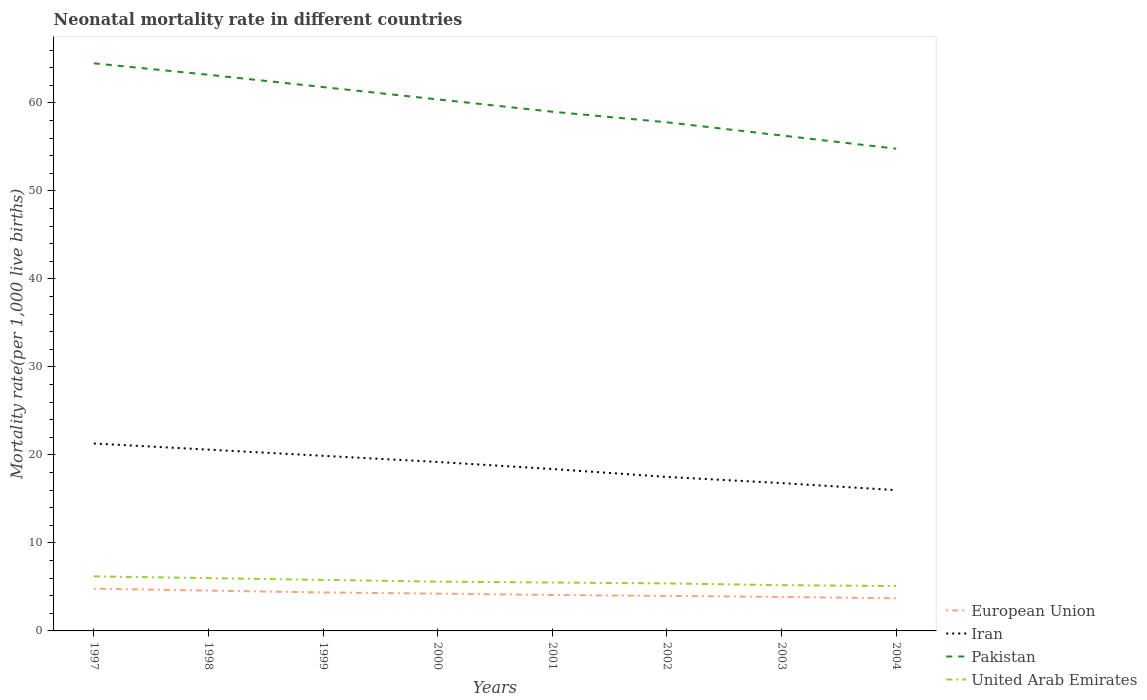How many different coloured lines are there?
Provide a succinct answer. 4. Across all years, what is the maximum neonatal mortality rate in Pakistan?
Provide a short and direct response. 54.8. What is the total neonatal mortality rate in Pakistan in the graph?
Provide a short and direct response. 8.4. What is the difference between the highest and the second highest neonatal mortality rate in European Union?
Provide a short and direct response. 1.09. What is the difference between the highest and the lowest neonatal mortality rate in United Arab Emirates?
Make the answer very short. 3. Is the neonatal mortality rate in United Arab Emirates strictly greater than the neonatal mortality rate in Iran over the years?
Provide a short and direct response. Yes. Are the values on the major ticks of Y-axis written in scientific E-notation?
Your response must be concise. No. Where does the legend appear in the graph?
Provide a succinct answer. Bottom right. How are the legend labels stacked?
Ensure brevity in your answer.  Vertical. What is the title of the graph?
Provide a succinct answer. Neonatal mortality rate in different countries. What is the label or title of the Y-axis?
Keep it short and to the point. Mortality rate(per 1,0 live births). What is the Mortality rate(per 1,000 live births) in European Union in 1997?
Give a very brief answer. 4.8. What is the Mortality rate(per 1,000 live births) of Iran in 1997?
Provide a short and direct response. 21.3. What is the Mortality rate(per 1,000 live births) of Pakistan in 1997?
Your answer should be compact. 64.5. What is the Mortality rate(per 1,000 live births) in United Arab Emirates in 1997?
Your response must be concise. 6.2. What is the Mortality rate(per 1,000 live births) of European Union in 1998?
Ensure brevity in your answer.  4.58. What is the Mortality rate(per 1,000 live births) in Iran in 1998?
Provide a succinct answer. 20.6. What is the Mortality rate(per 1,000 live births) in Pakistan in 1998?
Offer a very short reply. 63.2. What is the Mortality rate(per 1,000 live births) in European Union in 1999?
Your answer should be very brief. 4.37. What is the Mortality rate(per 1,000 live births) in Pakistan in 1999?
Your answer should be very brief. 61.8. What is the Mortality rate(per 1,000 live births) of United Arab Emirates in 1999?
Your answer should be very brief. 5.8. What is the Mortality rate(per 1,000 live births) in European Union in 2000?
Give a very brief answer. 4.24. What is the Mortality rate(per 1,000 live births) of Iran in 2000?
Keep it short and to the point. 19.2. What is the Mortality rate(per 1,000 live births) in Pakistan in 2000?
Offer a terse response. 60.4. What is the Mortality rate(per 1,000 live births) in European Union in 2001?
Make the answer very short. 4.08. What is the Mortality rate(per 1,000 live births) of Iran in 2001?
Provide a succinct answer. 18.4. What is the Mortality rate(per 1,000 live births) in European Union in 2002?
Your response must be concise. 3.98. What is the Mortality rate(per 1,000 live births) in Pakistan in 2002?
Make the answer very short. 57.8. What is the Mortality rate(per 1,000 live births) of United Arab Emirates in 2002?
Your response must be concise. 5.4. What is the Mortality rate(per 1,000 live births) of European Union in 2003?
Keep it short and to the point. 3.86. What is the Mortality rate(per 1,000 live births) in Pakistan in 2003?
Provide a short and direct response. 56.3. What is the Mortality rate(per 1,000 live births) in European Union in 2004?
Provide a succinct answer. 3.71. What is the Mortality rate(per 1,000 live births) of Iran in 2004?
Your response must be concise. 16. What is the Mortality rate(per 1,000 live births) of Pakistan in 2004?
Your response must be concise. 54.8. What is the Mortality rate(per 1,000 live births) in United Arab Emirates in 2004?
Give a very brief answer. 5.1. Across all years, what is the maximum Mortality rate(per 1,000 live births) in European Union?
Your answer should be very brief. 4.8. Across all years, what is the maximum Mortality rate(per 1,000 live births) of Iran?
Your answer should be very brief. 21.3. Across all years, what is the maximum Mortality rate(per 1,000 live births) of Pakistan?
Give a very brief answer. 64.5. Across all years, what is the maximum Mortality rate(per 1,000 live births) of United Arab Emirates?
Offer a terse response. 6.2. Across all years, what is the minimum Mortality rate(per 1,000 live births) in European Union?
Provide a succinct answer. 3.71. Across all years, what is the minimum Mortality rate(per 1,000 live births) of Iran?
Provide a short and direct response. 16. Across all years, what is the minimum Mortality rate(per 1,000 live births) of Pakistan?
Your answer should be very brief. 54.8. Across all years, what is the minimum Mortality rate(per 1,000 live births) of United Arab Emirates?
Make the answer very short. 5.1. What is the total Mortality rate(per 1,000 live births) of European Union in the graph?
Your answer should be compact. 33.62. What is the total Mortality rate(per 1,000 live births) in Iran in the graph?
Your answer should be compact. 149.7. What is the total Mortality rate(per 1,000 live births) in Pakistan in the graph?
Your answer should be very brief. 477.8. What is the total Mortality rate(per 1,000 live births) in United Arab Emirates in the graph?
Ensure brevity in your answer.  44.8. What is the difference between the Mortality rate(per 1,000 live births) of European Union in 1997 and that in 1998?
Provide a short and direct response. 0.22. What is the difference between the Mortality rate(per 1,000 live births) of European Union in 1997 and that in 1999?
Your answer should be very brief. 0.43. What is the difference between the Mortality rate(per 1,000 live births) of Iran in 1997 and that in 1999?
Give a very brief answer. 1.4. What is the difference between the Mortality rate(per 1,000 live births) of European Union in 1997 and that in 2000?
Your response must be concise. 0.56. What is the difference between the Mortality rate(per 1,000 live births) in United Arab Emirates in 1997 and that in 2000?
Provide a short and direct response. 0.6. What is the difference between the Mortality rate(per 1,000 live births) of European Union in 1997 and that in 2001?
Your response must be concise. 0.72. What is the difference between the Mortality rate(per 1,000 live births) in Pakistan in 1997 and that in 2001?
Your answer should be very brief. 5.5. What is the difference between the Mortality rate(per 1,000 live births) of United Arab Emirates in 1997 and that in 2001?
Keep it short and to the point. 0.7. What is the difference between the Mortality rate(per 1,000 live births) of European Union in 1997 and that in 2002?
Keep it short and to the point. 0.82. What is the difference between the Mortality rate(per 1,000 live births) in Iran in 1997 and that in 2002?
Your answer should be compact. 3.8. What is the difference between the Mortality rate(per 1,000 live births) of United Arab Emirates in 1997 and that in 2002?
Keep it short and to the point. 0.8. What is the difference between the Mortality rate(per 1,000 live births) of European Union in 1997 and that in 2003?
Provide a short and direct response. 0.94. What is the difference between the Mortality rate(per 1,000 live births) of Iran in 1997 and that in 2003?
Ensure brevity in your answer.  4.5. What is the difference between the Mortality rate(per 1,000 live births) of European Union in 1997 and that in 2004?
Your answer should be very brief. 1.09. What is the difference between the Mortality rate(per 1,000 live births) in Iran in 1997 and that in 2004?
Offer a very short reply. 5.3. What is the difference between the Mortality rate(per 1,000 live births) of United Arab Emirates in 1997 and that in 2004?
Your response must be concise. 1.1. What is the difference between the Mortality rate(per 1,000 live births) in European Union in 1998 and that in 1999?
Provide a short and direct response. 0.21. What is the difference between the Mortality rate(per 1,000 live births) of United Arab Emirates in 1998 and that in 1999?
Your response must be concise. 0.2. What is the difference between the Mortality rate(per 1,000 live births) of European Union in 1998 and that in 2000?
Provide a short and direct response. 0.34. What is the difference between the Mortality rate(per 1,000 live births) of Pakistan in 1998 and that in 2000?
Your answer should be compact. 2.8. What is the difference between the Mortality rate(per 1,000 live births) in United Arab Emirates in 1998 and that in 2000?
Your response must be concise. 0.4. What is the difference between the Mortality rate(per 1,000 live births) in European Union in 1998 and that in 2001?
Keep it short and to the point. 0.5. What is the difference between the Mortality rate(per 1,000 live births) of United Arab Emirates in 1998 and that in 2001?
Provide a short and direct response. 0.5. What is the difference between the Mortality rate(per 1,000 live births) in European Union in 1998 and that in 2002?
Keep it short and to the point. 0.6. What is the difference between the Mortality rate(per 1,000 live births) of Pakistan in 1998 and that in 2002?
Make the answer very short. 5.4. What is the difference between the Mortality rate(per 1,000 live births) of European Union in 1998 and that in 2003?
Provide a short and direct response. 0.72. What is the difference between the Mortality rate(per 1,000 live births) of Pakistan in 1998 and that in 2003?
Provide a succinct answer. 6.9. What is the difference between the Mortality rate(per 1,000 live births) of United Arab Emirates in 1998 and that in 2003?
Offer a terse response. 0.8. What is the difference between the Mortality rate(per 1,000 live births) of European Union in 1998 and that in 2004?
Ensure brevity in your answer.  0.87. What is the difference between the Mortality rate(per 1,000 live births) of Iran in 1998 and that in 2004?
Offer a very short reply. 4.6. What is the difference between the Mortality rate(per 1,000 live births) of European Union in 1999 and that in 2000?
Provide a short and direct response. 0.13. What is the difference between the Mortality rate(per 1,000 live births) of United Arab Emirates in 1999 and that in 2000?
Provide a short and direct response. 0.2. What is the difference between the Mortality rate(per 1,000 live births) of European Union in 1999 and that in 2001?
Keep it short and to the point. 0.29. What is the difference between the Mortality rate(per 1,000 live births) of European Union in 1999 and that in 2002?
Provide a succinct answer. 0.39. What is the difference between the Mortality rate(per 1,000 live births) of Iran in 1999 and that in 2002?
Provide a succinct answer. 2.4. What is the difference between the Mortality rate(per 1,000 live births) in Pakistan in 1999 and that in 2002?
Offer a very short reply. 4. What is the difference between the Mortality rate(per 1,000 live births) of European Union in 1999 and that in 2003?
Your answer should be compact. 0.51. What is the difference between the Mortality rate(per 1,000 live births) in Iran in 1999 and that in 2003?
Offer a very short reply. 3.1. What is the difference between the Mortality rate(per 1,000 live births) in European Union in 1999 and that in 2004?
Give a very brief answer. 0.66. What is the difference between the Mortality rate(per 1,000 live births) in Iran in 1999 and that in 2004?
Ensure brevity in your answer.  3.9. What is the difference between the Mortality rate(per 1,000 live births) of European Union in 2000 and that in 2001?
Offer a terse response. 0.15. What is the difference between the Mortality rate(per 1,000 live births) of Pakistan in 2000 and that in 2001?
Keep it short and to the point. 1.4. What is the difference between the Mortality rate(per 1,000 live births) in European Union in 2000 and that in 2002?
Keep it short and to the point. 0.26. What is the difference between the Mortality rate(per 1,000 live births) in European Union in 2000 and that in 2003?
Make the answer very short. 0.38. What is the difference between the Mortality rate(per 1,000 live births) of Iran in 2000 and that in 2003?
Keep it short and to the point. 2.4. What is the difference between the Mortality rate(per 1,000 live births) in United Arab Emirates in 2000 and that in 2003?
Provide a short and direct response. 0.4. What is the difference between the Mortality rate(per 1,000 live births) of European Union in 2000 and that in 2004?
Offer a terse response. 0.53. What is the difference between the Mortality rate(per 1,000 live births) in Pakistan in 2000 and that in 2004?
Keep it short and to the point. 5.6. What is the difference between the Mortality rate(per 1,000 live births) of European Union in 2001 and that in 2002?
Ensure brevity in your answer.  0.11. What is the difference between the Mortality rate(per 1,000 live births) of Iran in 2001 and that in 2002?
Your answer should be compact. 0.9. What is the difference between the Mortality rate(per 1,000 live births) in European Union in 2001 and that in 2003?
Make the answer very short. 0.22. What is the difference between the Mortality rate(per 1,000 live births) in United Arab Emirates in 2001 and that in 2003?
Make the answer very short. 0.3. What is the difference between the Mortality rate(per 1,000 live births) of European Union in 2001 and that in 2004?
Provide a short and direct response. 0.37. What is the difference between the Mortality rate(per 1,000 live births) of Iran in 2001 and that in 2004?
Keep it short and to the point. 2.4. What is the difference between the Mortality rate(per 1,000 live births) in European Union in 2002 and that in 2003?
Provide a short and direct response. 0.12. What is the difference between the Mortality rate(per 1,000 live births) of Iran in 2002 and that in 2003?
Offer a terse response. 0.7. What is the difference between the Mortality rate(per 1,000 live births) of United Arab Emirates in 2002 and that in 2003?
Keep it short and to the point. 0.2. What is the difference between the Mortality rate(per 1,000 live births) of European Union in 2002 and that in 2004?
Your answer should be very brief. 0.27. What is the difference between the Mortality rate(per 1,000 live births) of Pakistan in 2002 and that in 2004?
Give a very brief answer. 3. What is the difference between the Mortality rate(per 1,000 live births) of European Union in 2003 and that in 2004?
Provide a succinct answer. 0.15. What is the difference between the Mortality rate(per 1,000 live births) in Iran in 2003 and that in 2004?
Ensure brevity in your answer.  0.8. What is the difference between the Mortality rate(per 1,000 live births) in Pakistan in 2003 and that in 2004?
Ensure brevity in your answer.  1.5. What is the difference between the Mortality rate(per 1,000 live births) of European Union in 1997 and the Mortality rate(per 1,000 live births) of Iran in 1998?
Ensure brevity in your answer.  -15.8. What is the difference between the Mortality rate(per 1,000 live births) of European Union in 1997 and the Mortality rate(per 1,000 live births) of Pakistan in 1998?
Provide a succinct answer. -58.4. What is the difference between the Mortality rate(per 1,000 live births) of European Union in 1997 and the Mortality rate(per 1,000 live births) of United Arab Emirates in 1998?
Your answer should be compact. -1.2. What is the difference between the Mortality rate(per 1,000 live births) in Iran in 1997 and the Mortality rate(per 1,000 live births) in Pakistan in 1998?
Ensure brevity in your answer.  -41.9. What is the difference between the Mortality rate(per 1,000 live births) of Iran in 1997 and the Mortality rate(per 1,000 live births) of United Arab Emirates in 1998?
Your answer should be very brief. 15.3. What is the difference between the Mortality rate(per 1,000 live births) of Pakistan in 1997 and the Mortality rate(per 1,000 live births) of United Arab Emirates in 1998?
Give a very brief answer. 58.5. What is the difference between the Mortality rate(per 1,000 live births) in European Union in 1997 and the Mortality rate(per 1,000 live births) in Iran in 1999?
Provide a short and direct response. -15.1. What is the difference between the Mortality rate(per 1,000 live births) of European Union in 1997 and the Mortality rate(per 1,000 live births) of Pakistan in 1999?
Keep it short and to the point. -57. What is the difference between the Mortality rate(per 1,000 live births) of European Union in 1997 and the Mortality rate(per 1,000 live births) of United Arab Emirates in 1999?
Make the answer very short. -1. What is the difference between the Mortality rate(per 1,000 live births) in Iran in 1997 and the Mortality rate(per 1,000 live births) in Pakistan in 1999?
Make the answer very short. -40.5. What is the difference between the Mortality rate(per 1,000 live births) in Pakistan in 1997 and the Mortality rate(per 1,000 live births) in United Arab Emirates in 1999?
Offer a terse response. 58.7. What is the difference between the Mortality rate(per 1,000 live births) of European Union in 1997 and the Mortality rate(per 1,000 live births) of Iran in 2000?
Your response must be concise. -14.4. What is the difference between the Mortality rate(per 1,000 live births) of European Union in 1997 and the Mortality rate(per 1,000 live births) of Pakistan in 2000?
Provide a short and direct response. -55.6. What is the difference between the Mortality rate(per 1,000 live births) of European Union in 1997 and the Mortality rate(per 1,000 live births) of United Arab Emirates in 2000?
Your answer should be compact. -0.8. What is the difference between the Mortality rate(per 1,000 live births) in Iran in 1997 and the Mortality rate(per 1,000 live births) in Pakistan in 2000?
Keep it short and to the point. -39.1. What is the difference between the Mortality rate(per 1,000 live births) in Pakistan in 1997 and the Mortality rate(per 1,000 live births) in United Arab Emirates in 2000?
Your answer should be compact. 58.9. What is the difference between the Mortality rate(per 1,000 live births) of European Union in 1997 and the Mortality rate(per 1,000 live births) of Iran in 2001?
Ensure brevity in your answer.  -13.6. What is the difference between the Mortality rate(per 1,000 live births) of European Union in 1997 and the Mortality rate(per 1,000 live births) of Pakistan in 2001?
Ensure brevity in your answer.  -54.2. What is the difference between the Mortality rate(per 1,000 live births) of European Union in 1997 and the Mortality rate(per 1,000 live births) of United Arab Emirates in 2001?
Offer a very short reply. -0.7. What is the difference between the Mortality rate(per 1,000 live births) in Iran in 1997 and the Mortality rate(per 1,000 live births) in Pakistan in 2001?
Keep it short and to the point. -37.7. What is the difference between the Mortality rate(per 1,000 live births) in Pakistan in 1997 and the Mortality rate(per 1,000 live births) in United Arab Emirates in 2001?
Your answer should be compact. 59. What is the difference between the Mortality rate(per 1,000 live births) in European Union in 1997 and the Mortality rate(per 1,000 live births) in Iran in 2002?
Offer a very short reply. -12.7. What is the difference between the Mortality rate(per 1,000 live births) of European Union in 1997 and the Mortality rate(per 1,000 live births) of Pakistan in 2002?
Offer a very short reply. -53. What is the difference between the Mortality rate(per 1,000 live births) of European Union in 1997 and the Mortality rate(per 1,000 live births) of United Arab Emirates in 2002?
Ensure brevity in your answer.  -0.6. What is the difference between the Mortality rate(per 1,000 live births) of Iran in 1997 and the Mortality rate(per 1,000 live births) of Pakistan in 2002?
Give a very brief answer. -36.5. What is the difference between the Mortality rate(per 1,000 live births) in Pakistan in 1997 and the Mortality rate(per 1,000 live births) in United Arab Emirates in 2002?
Ensure brevity in your answer.  59.1. What is the difference between the Mortality rate(per 1,000 live births) in European Union in 1997 and the Mortality rate(per 1,000 live births) in Iran in 2003?
Your answer should be compact. -12. What is the difference between the Mortality rate(per 1,000 live births) of European Union in 1997 and the Mortality rate(per 1,000 live births) of Pakistan in 2003?
Offer a terse response. -51.5. What is the difference between the Mortality rate(per 1,000 live births) in European Union in 1997 and the Mortality rate(per 1,000 live births) in United Arab Emirates in 2003?
Provide a succinct answer. -0.4. What is the difference between the Mortality rate(per 1,000 live births) in Iran in 1997 and the Mortality rate(per 1,000 live births) in Pakistan in 2003?
Your response must be concise. -35. What is the difference between the Mortality rate(per 1,000 live births) in Pakistan in 1997 and the Mortality rate(per 1,000 live births) in United Arab Emirates in 2003?
Keep it short and to the point. 59.3. What is the difference between the Mortality rate(per 1,000 live births) in European Union in 1997 and the Mortality rate(per 1,000 live births) in Iran in 2004?
Keep it short and to the point. -11.2. What is the difference between the Mortality rate(per 1,000 live births) of European Union in 1997 and the Mortality rate(per 1,000 live births) of Pakistan in 2004?
Make the answer very short. -50. What is the difference between the Mortality rate(per 1,000 live births) in European Union in 1997 and the Mortality rate(per 1,000 live births) in United Arab Emirates in 2004?
Provide a short and direct response. -0.3. What is the difference between the Mortality rate(per 1,000 live births) of Iran in 1997 and the Mortality rate(per 1,000 live births) of Pakistan in 2004?
Provide a short and direct response. -33.5. What is the difference between the Mortality rate(per 1,000 live births) in Pakistan in 1997 and the Mortality rate(per 1,000 live births) in United Arab Emirates in 2004?
Keep it short and to the point. 59.4. What is the difference between the Mortality rate(per 1,000 live births) of European Union in 1998 and the Mortality rate(per 1,000 live births) of Iran in 1999?
Your answer should be compact. -15.32. What is the difference between the Mortality rate(per 1,000 live births) in European Union in 1998 and the Mortality rate(per 1,000 live births) in Pakistan in 1999?
Make the answer very short. -57.22. What is the difference between the Mortality rate(per 1,000 live births) of European Union in 1998 and the Mortality rate(per 1,000 live births) of United Arab Emirates in 1999?
Ensure brevity in your answer.  -1.22. What is the difference between the Mortality rate(per 1,000 live births) in Iran in 1998 and the Mortality rate(per 1,000 live births) in Pakistan in 1999?
Your response must be concise. -41.2. What is the difference between the Mortality rate(per 1,000 live births) in Pakistan in 1998 and the Mortality rate(per 1,000 live births) in United Arab Emirates in 1999?
Ensure brevity in your answer.  57.4. What is the difference between the Mortality rate(per 1,000 live births) of European Union in 1998 and the Mortality rate(per 1,000 live births) of Iran in 2000?
Give a very brief answer. -14.62. What is the difference between the Mortality rate(per 1,000 live births) of European Union in 1998 and the Mortality rate(per 1,000 live births) of Pakistan in 2000?
Make the answer very short. -55.82. What is the difference between the Mortality rate(per 1,000 live births) in European Union in 1998 and the Mortality rate(per 1,000 live births) in United Arab Emirates in 2000?
Your answer should be compact. -1.02. What is the difference between the Mortality rate(per 1,000 live births) of Iran in 1998 and the Mortality rate(per 1,000 live births) of Pakistan in 2000?
Your response must be concise. -39.8. What is the difference between the Mortality rate(per 1,000 live births) of Pakistan in 1998 and the Mortality rate(per 1,000 live births) of United Arab Emirates in 2000?
Keep it short and to the point. 57.6. What is the difference between the Mortality rate(per 1,000 live births) in European Union in 1998 and the Mortality rate(per 1,000 live births) in Iran in 2001?
Your answer should be compact. -13.82. What is the difference between the Mortality rate(per 1,000 live births) in European Union in 1998 and the Mortality rate(per 1,000 live births) in Pakistan in 2001?
Offer a terse response. -54.42. What is the difference between the Mortality rate(per 1,000 live births) of European Union in 1998 and the Mortality rate(per 1,000 live births) of United Arab Emirates in 2001?
Give a very brief answer. -0.92. What is the difference between the Mortality rate(per 1,000 live births) in Iran in 1998 and the Mortality rate(per 1,000 live births) in Pakistan in 2001?
Provide a short and direct response. -38.4. What is the difference between the Mortality rate(per 1,000 live births) in Iran in 1998 and the Mortality rate(per 1,000 live births) in United Arab Emirates in 2001?
Your answer should be very brief. 15.1. What is the difference between the Mortality rate(per 1,000 live births) of Pakistan in 1998 and the Mortality rate(per 1,000 live births) of United Arab Emirates in 2001?
Ensure brevity in your answer.  57.7. What is the difference between the Mortality rate(per 1,000 live births) in European Union in 1998 and the Mortality rate(per 1,000 live births) in Iran in 2002?
Offer a terse response. -12.92. What is the difference between the Mortality rate(per 1,000 live births) in European Union in 1998 and the Mortality rate(per 1,000 live births) in Pakistan in 2002?
Keep it short and to the point. -53.22. What is the difference between the Mortality rate(per 1,000 live births) of European Union in 1998 and the Mortality rate(per 1,000 live births) of United Arab Emirates in 2002?
Make the answer very short. -0.82. What is the difference between the Mortality rate(per 1,000 live births) in Iran in 1998 and the Mortality rate(per 1,000 live births) in Pakistan in 2002?
Your response must be concise. -37.2. What is the difference between the Mortality rate(per 1,000 live births) in Iran in 1998 and the Mortality rate(per 1,000 live births) in United Arab Emirates in 2002?
Ensure brevity in your answer.  15.2. What is the difference between the Mortality rate(per 1,000 live births) of Pakistan in 1998 and the Mortality rate(per 1,000 live births) of United Arab Emirates in 2002?
Ensure brevity in your answer.  57.8. What is the difference between the Mortality rate(per 1,000 live births) of European Union in 1998 and the Mortality rate(per 1,000 live births) of Iran in 2003?
Provide a short and direct response. -12.22. What is the difference between the Mortality rate(per 1,000 live births) of European Union in 1998 and the Mortality rate(per 1,000 live births) of Pakistan in 2003?
Keep it short and to the point. -51.72. What is the difference between the Mortality rate(per 1,000 live births) in European Union in 1998 and the Mortality rate(per 1,000 live births) in United Arab Emirates in 2003?
Offer a very short reply. -0.62. What is the difference between the Mortality rate(per 1,000 live births) of Iran in 1998 and the Mortality rate(per 1,000 live births) of Pakistan in 2003?
Keep it short and to the point. -35.7. What is the difference between the Mortality rate(per 1,000 live births) in Pakistan in 1998 and the Mortality rate(per 1,000 live births) in United Arab Emirates in 2003?
Provide a succinct answer. 58. What is the difference between the Mortality rate(per 1,000 live births) of European Union in 1998 and the Mortality rate(per 1,000 live births) of Iran in 2004?
Make the answer very short. -11.42. What is the difference between the Mortality rate(per 1,000 live births) in European Union in 1998 and the Mortality rate(per 1,000 live births) in Pakistan in 2004?
Provide a succinct answer. -50.22. What is the difference between the Mortality rate(per 1,000 live births) of European Union in 1998 and the Mortality rate(per 1,000 live births) of United Arab Emirates in 2004?
Ensure brevity in your answer.  -0.52. What is the difference between the Mortality rate(per 1,000 live births) in Iran in 1998 and the Mortality rate(per 1,000 live births) in Pakistan in 2004?
Keep it short and to the point. -34.2. What is the difference between the Mortality rate(per 1,000 live births) in Iran in 1998 and the Mortality rate(per 1,000 live births) in United Arab Emirates in 2004?
Make the answer very short. 15.5. What is the difference between the Mortality rate(per 1,000 live births) in Pakistan in 1998 and the Mortality rate(per 1,000 live births) in United Arab Emirates in 2004?
Ensure brevity in your answer.  58.1. What is the difference between the Mortality rate(per 1,000 live births) of European Union in 1999 and the Mortality rate(per 1,000 live births) of Iran in 2000?
Your response must be concise. -14.83. What is the difference between the Mortality rate(per 1,000 live births) of European Union in 1999 and the Mortality rate(per 1,000 live births) of Pakistan in 2000?
Your answer should be very brief. -56.03. What is the difference between the Mortality rate(per 1,000 live births) in European Union in 1999 and the Mortality rate(per 1,000 live births) in United Arab Emirates in 2000?
Make the answer very short. -1.23. What is the difference between the Mortality rate(per 1,000 live births) of Iran in 1999 and the Mortality rate(per 1,000 live births) of Pakistan in 2000?
Your response must be concise. -40.5. What is the difference between the Mortality rate(per 1,000 live births) of Iran in 1999 and the Mortality rate(per 1,000 live births) of United Arab Emirates in 2000?
Offer a very short reply. 14.3. What is the difference between the Mortality rate(per 1,000 live births) of Pakistan in 1999 and the Mortality rate(per 1,000 live births) of United Arab Emirates in 2000?
Keep it short and to the point. 56.2. What is the difference between the Mortality rate(per 1,000 live births) in European Union in 1999 and the Mortality rate(per 1,000 live births) in Iran in 2001?
Offer a terse response. -14.03. What is the difference between the Mortality rate(per 1,000 live births) of European Union in 1999 and the Mortality rate(per 1,000 live births) of Pakistan in 2001?
Your response must be concise. -54.63. What is the difference between the Mortality rate(per 1,000 live births) of European Union in 1999 and the Mortality rate(per 1,000 live births) of United Arab Emirates in 2001?
Provide a succinct answer. -1.13. What is the difference between the Mortality rate(per 1,000 live births) of Iran in 1999 and the Mortality rate(per 1,000 live births) of Pakistan in 2001?
Provide a short and direct response. -39.1. What is the difference between the Mortality rate(per 1,000 live births) in Pakistan in 1999 and the Mortality rate(per 1,000 live births) in United Arab Emirates in 2001?
Provide a succinct answer. 56.3. What is the difference between the Mortality rate(per 1,000 live births) in European Union in 1999 and the Mortality rate(per 1,000 live births) in Iran in 2002?
Offer a very short reply. -13.13. What is the difference between the Mortality rate(per 1,000 live births) in European Union in 1999 and the Mortality rate(per 1,000 live births) in Pakistan in 2002?
Your response must be concise. -53.43. What is the difference between the Mortality rate(per 1,000 live births) in European Union in 1999 and the Mortality rate(per 1,000 live births) in United Arab Emirates in 2002?
Ensure brevity in your answer.  -1.03. What is the difference between the Mortality rate(per 1,000 live births) in Iran in 1999 and the Mortality rate(per 1,000 live births) in Pakistan in 2002?
Your answer should be very brief. -37.9. What is the difference between the Mortality rate(per 1,000 live births) of Iran in 1999 and the Mortality rate(per 1,000 live births) of United Arab Emirates in 2002?
Your response must be concise. 14.5. What is the difference between the Mortality rate(per 1,000 live births) in Pakistan in 1999 and the Mortality rate(per 1,000 live births) in United Arab Emirates in 2002?
Give a very brief answer. 56.4. What is the difference between the Mortality rate(per 1,000 live births) in European Union in 1999 and the Mortality rate(per 1,000 live births) in Iran in 2003?
Keep it short and to the point. -12.43. What is the difference between the Mortality rate(per 1,000 live births) of European Union in 1999 and the Mortality rate(per 1,000 live births) of Pakistan in 2003?
Give a very brief answer. -51.93. What is the difference between the Mortality rate(per 1,000 live births) in European Union in 1999 and the Mortality rate(per 1,000 live births) in United Arab Emirates in 2003?
Your response must be concise. -0.83. What is the difference between the Mortality rate(per 1,000 live births) in Iran in 1999 and the Mortality rate(per 1,000 live births) in Pakistan in 2003?
Keep it short and to the point. -36.4. What is the difference between the Mortality rate(per 1,000 live births) of Pakistan in 1999 and the Mortality rate(per 1,000 live births) of United Arab Emirates in 2003?
Your answer should be very brief. 56.6. What is the difference between the Mortality rate(per 1,000 live births) in European Union in 1999 and the Mortality rate(per 1,000 live births) in Iran in 2004?
Provide a succinct answer. -11.63. What is the difference between the Mortality rate(per 1,000 live births) of European Union in 1999 and the Mortality rate(per 1,000 live births) of Pakistan in 2004?
Keep it short and to the point. -50.43. What is the difference between the Mortality rate(per 1,000 live births) of European Union in 1999 and the Mortality rate(per 1,000 live births) of United Arab Emirates in 2004?
Ensure brevity in your answer.  -0.73. What is the difference between the Mortality rate(per 1,000 live births) of Iran in 1999 and the Mortality rate(per 1,000 live births) of Pakistan in 2004?
Offer a terse response. -34.9. What is the difference between the Mortality rate(per 1,000 live births) of Iran in 1999 and the Mortality rate(per 1,000 live births) of United Arab Emirates in 2004?
Your answer should be compact. 14.8. What is the difference between the Mortality rate(per 1,000 live births) in Pakistan in 1999 and the Mortality rate(per 1,000 live births) in United Arab Emirates in 2004?
Offer a very short reply. 56.7. What is the difference between the Mortality rate(per 1,000 live births) in European Union in 2000 and the Mortality rate(per 1,000 live births) in Iran in 2001?
Your answer should be compact. -14.16. What is the difference between the Mortality rate(per 1,000 live births) in European Union in 2000 and the Mortality rate(per 1,000 live births) in Pakistan in 2001?
Provide a short and direct response. -54.76. What is the difference between the Mortality rate(per 1,000 live births) of European Union in 2000 and the Mortality rate(per 1,000 live births) of United Arab Emirates in 2001?
Make the answer very short. -1.26. What is the difference between the Mortality rate(per 1,000 live births) of Iran in 2000 and the Mortality rate(per 1,000 live births) of Pakistan in 2001?
Offer a terse response. -39.8. What is the difference between the Mortality rate(per 1,000 live births) in Iran in 2000 and the Mortality rate(per 1,000 live births) in United Arab Emirates in 2001?
Provide a succinct answer. 13.7. What is the difference between the Mortality rate(per 1,000 live births) of Pakistan in 2000 and the Mortality rate(per 1,000 live births) of United Arab Emirates in 2001?
Make the answer very short. 54.9. What is the difference between the Mortality rate(per 1,000 live births) in European Union in 2000 and the Mortality rate(per 1,000 live births) in Iran in 2002?
Keep it short and to the point. -13.26. What is the difference between the Mortality rate(per 1,000 live births) in European Union in 2000 and the Mortality rate(per 1,000 live births) in Pakistan in 2002?
Ensure brevity in your answer.  -53.56. What is the difference between the Mortality rate(per 1,000 live births) in European Union in 2000 and the Mortality rate(per 1,000 live births) in United Arab Emirates in 2002?
Your answer should be compact. -1.16. What is the difference between the Mortality rate(per 1,000 live births) of Iran in 2000 and the Mortality rate(per 1,000 live births) of Pakistan in 2002?
Make the answer very short. -38.6. What is the difference between the Mortality rate(per 1,000 live births) of European Union in 2000 and the Mortality rate(per 1,000 live births) of Iran in 2003?
Your answer should be very brief. -12.56. What is the difference between the Mortality rate(per 1,000 live births) in European Union in 2000 and the Mortality rate(per 1,000 live births) in Pakistan in 2003?
Keep it short and to the point. -52.06. What is the difference between the Mortality rate(per 1,000 live births) of European Union in 2000 and the Mortality rate(per 1,000 live births) of United Arab Emirates in 2003?
Your answer should be compact. -0.96. What is the difference between the Mortality rate(per 1,000 live births) of Iran in 2000 and the Mortality rate(per 1,000 live births) of Pakistan in 2003?
Your response must be concise. -37.1. What is the difference between the Mortality rate(per 1,000 live births) of Pakistan in 2000 and the Mortality rate(per 1,000 live births) of United Arab Emirates in 2003?
Offer a very short reply. 55.2. What is the difference between the Mortality rate(per 1,000 live births) in European Union in 2000 and the Mortality rate(per 1,000 live births) in Iran in 2004?
Provide a short and direct response. -11.76. What is the difference between the Mortality rate(per 1,000 live births) of European Union in 2000 and the Mortality rate(per 1,000 live births) of Pakistan in 2004?
Give a very brief answer. -50.56. What is the difference between the Mortality rate(per 1,000 live births) of European Union in 2000 and the Mortality rate(per 1,000 live births) of United Arab Emirates in 2004?
Offer a terse response. -0.86. What is the difference between the Mortality rate(per 1,000 live births) in Iran in 2000 and the Mortality rate(per 1,000 live births) in Pakistan in 2004?
Offer a very short reply. -35.6. What is the difference between the Mortality rate(per 1,000 live births) in Iran in 2000 and the Mortality rate(per 1,000 live births) in United Arab Emirates in 2004?
Provide a succinct answer. 14.1. What is the difference between the Mortality rate(per 1,000 live births) in Pakistan in 2000 and the Mortality rate(per 1,000 live births) in United Arab Emirates in 2004?
Provide a short and direct response. 55.3. What is the difference between the Mortality rate(per 1,000 live births) of European Union in 2001 and the Mortality rate(per 1,000 live births) of Iran in 2002?
Ensure brevity in your answer.  -13.42. What is the difference between the Mortality rate(per 1,000 live births) in European Union in 2001 and the Mortality rate(per 1,000 live births) in Pakistan in 2002?
Your answer should be compact. -53.72. What is the difference between the Mortality rate(per 1,000 live births) of European Union in 2001 and the Mortality rate(per 1,000 live births) of United Arab Emirates in 2002?
Your response must be concise. -1.32. What is the difference between the Mortality rate(per 1,000 live births) in Iran in 2001 and the Mortality rate(per 1,000 live births) in Pakistan in 2002?
Offer a terse response. -39.4. What is the difference between the Mortality rate(per 1,000 live births) of Pakistan in 2001 and the Mortality rate(per 1,000 live births) of United Arab Emirates in 2002?
Provide a succinct answer. 53.6. What is the difference between the Mortality rate(per 1,000 live births) of European Union in 2001 and the Mortality rate(per 1,000 live births) of Iran in 2003?
Provide a short and direct response. -12.72. What is the difference between the Mortality rate(per 1,000 live births) in European Union in 2001 and the Mortality rate(per 1,000 live births) in Pakistan in 2003?
Keep it short and to the point. -52.22. What is the difference between the Mortality rate(per 1,000 live births) in European Union in 2001 and the Mortality rate(per 1,000 live births) in United Arab Emirates in 2003?
Offer a very short reply. -1.12. What is the difference between the Mortality rate(per 1,000 live births) in Iran in 2001 and the Mortality rate(per 1,000 live births) in Pakistan in 2003?
Give a very brief answer. -37.9. What is the difference between the Mortality rate(per 1,000 live births) in Pakistan in 2001 and the Mortality rate(per 1,000 live births) in United Arab Emirates in 2003?
Your answer should be compact. 53.8. What is the difference between the Mortality rate(per 1,000 live births) in European Union in 2001 and the Mortality rate(per 1,000 live births) in Iran in 2004?
Offer a very short reply. -11.92. What is the difference between the Mortality rate(per 1,000 live births) of European Union in 2001 and the Mortality rate(per 1,000 live births) of Pakistan in 2004?
Ensure brevity in your answer.  -50.72. What is the difference between the Mortality rate(per 1,000 live births) in European Union in 2001 and the Mortality rate(per 1,000 live births) in United Arab Emirates in 2004?
Your answer should be compact. -1.02. What is the difference between the Mortality rate(per 1,000 live births) in Iran in 2001 and the Mortality rate(per 1,000 live births) in Pakistan in 2004?
Your response must be concise. -36.4. What is the difference between the Mortality rate(per 1,000 live births) in Iran in 2001 and the Mortality rate(per 1,000 live births) in United Arab Emirates in 2004?
Keep it short and to the point. 13.3. What is the difference between the Mortality rate(per 1,000 live births) of Pakistan in 2001 and the Mortality rate(per 1,000 live births) of United Arab Emirates in 2004?
Keep it short and to the point. 53.9. What is the difference between the Mortality rate(per 1,000 live births) of European Union in 2002 and the Mortality rate(per 1,000 live births) of Iran in 2003?
Give a very brief answer. -12.82. What is the difference between the Mortality rate(per 1,000 live births) of European Union in 2002 and the Mortality rate(per 1,000 live births) of Pakistan in 2003?
Provide a short and direct response. -52.32. What is the difference between the Mortality rate(per 1,000 live births) of European Union in 2002 and the Mortality rate(per 1,000 live births) of United Arab Emirates in 2003?
Your answer should be very brief. -1.22. What is the difference between the Mortality rate(per 1,000 live births) in Iran in 2002 and the Mortality rate(per 1,000 live births) in Pakistan in 2003?
Your response must be concise. -38.8. What is the difference between the Mortality rate(per 1,000 live births) in Pakistan in 2002 and the Mortality rate(per 1,000 live births) in United Arab Emirates in 2003?
Provide a short and direct response. 52.6. What is the difference between the Mortality rate(per 1,000 live births) of European Union in 2002 and the Mortality rate(per 1,000 live births) of Iran in 2004?
Your answer should be very brief. -12.02. What is the difference between the Mortality rate(per 1,000 live births) of European Union in 2002 and the Mortality rate(per 1,000 live births) of Pakistan in 2004?
Ensure brevity in your answer.  -50.82. What is the difference between the Mortality rate(per 1,000 live births) in European Union in 2002 and the Mortality rate(per 1,000 live births) in United Arab Emirates in 2004?
Provide a short and direct response. -1.12. What is the difference between the Mortality rate(per 1,000 live births) of Iran in 2002 and the Mortality rate(per 1,000 live births) of Pakistan in 2004?
Your answer should be very brief. -37.3. What is the difference between the Mortality rate(per 1,000 live births) in Iran in 2002 and the Mortality rate(per 1,000 live births) in United Arab Emirates in 2004?
Offer a terse response. 12.4. What is the difference between the Mortality rate(per 1,000 live births) of Pakistan in 2002 and the Mortality rate(per 1,000 live births) of United Arab Emirates in 2004?
Your response must be concise. 52.7. What is the difference between the Mortality rate(per 1,000 live births) of European Union in 2003 and the Mortality rate(per 1,000 live births) of Iran in 2004?
Provide a short and direct response. -12.14. What is the difference between the Mortality rate(per 1,000 live births) in European Union in 2003 and the Mortality rate(per 1,000 live births) in Pakistan in 2004?
Ensure brevity in your answer.  -50.94. What is the difference between the Mortality rate(per 1,000 live births) in European Union in 2003 and the Mortality rate(per 1,000 live births) in United Arab Emirates in 2004?
Make the answer very short. -1.24. What is the difference between the Mortality rate(per 1,000 live births) in Iran in 2003 and the Mortality rate(per 1,000 live births) in Pakistan in 2004?
Your answer should be compact. -38. What is the difference between the Mortality rate(per 1,000 live births) in Iran in 2003 and the Mortality rate(per 1,000 live births) in United Arab Emirates in 2004?
Offer a very short reply. 11.7. What is the difference between the Mortality rate(per 1,000 live births) in Pakistan in 2003 and the Mortality rate(per 1,000 live births) in United Arab Emirates in 2004?
Make the answer very short. 51.2. What is the average Mortality rate(per 1,000 live births) of European Union per year?
Provide a short and direct response. 4.2. What is the average Mortality rate(per 1,000 live births) of Iran per year?
Your response must be concise. 18.71. What is the average Mortality rate(per 1,000 live births) of Pakistan per year?
Give a very brief answer. 59.73. What is the average Mortality rate(per 1,000 live births) in United Arab Emirates per year?
Provide a short and direct response. 5.6. In the year 1997, what is the difference between the Mortality rate(per 1,000 live births) of European Union and Mortality rate(per 1,000 live births) of Iran?
Provide a short and direct response. -16.5. In the year 1997, what is the difference between the Mortality rate(per 1,000 live births) of European Union and Mortality rate(per 1,000 live births) of Pakistan?
Your answer should be compact. -59.7. In the year 1997, what is the difference between the Mortality rate(per 1,000 live births) in European Union and Mortality rate(per 1,000 live births) in United Arab Emirates?
Keep it short and to the point. -1.4. In the year 1997, what is the difference between the Mortality rate(per 1,000 live births) of Iran and Mortality rate(per 1,000 live births) of Pakistan?
Give a very brief answer. -43.2. In the year 1997, what is the difference between the Mortality rate(per 1,000 live births) in Iran and Mortality rate(per 1,000 live births) in United Arab Emirates?
Offer a terse response. 15.1. In the year 1997, what is the difference between the Mortality rate(per 1,000 live births) of Pakistan and Mortality rate(per 1,000 live births) of United Arab Emirates?
Offer a very short reply. 58.3. In the year 1998, what is the difference between the Mortality rate(per 1,000 live births) of European Union and Mortality rate(per 1,000 live births) of Iran?
Ensure brevity in your answer.  -16.02. In the year 1998, what is the difference between the Mortality rate(per 1,000 live births) of European Union and Mortality rate(per 1,000 live births) of Pakistan?
Your answer should be very brief. -58.62. In the year 1998, what is the difference between the Mortality rate(per 1,000 live births) of European Union and Mortality rate(per 1,000 live births) of United Arab Emirates?
Your answer should be very brief. -1.42. In the year 1998, what is the difference between the Mortality rate(per 1,000 live births) in Iran and Mortality rate(per 1,000 live births) in Pakistan?
Ensure brevity in your answer.  -42.6. In the year 1998, what is the difference between the Mortality rate(per 1,000 live births) of Pakistan and Mortality rate(per 1,000 live births) of United Arab Emirates?
Offer a terse response. 57.2. In the year 1999, what is the difference between the Mortality rate(per 1,000 live births) in European Union and Mortality rate(per 1,000 live births) in Iran?
Make the answer very short. -15.53. In the year 1999, what is the difference between the Mortality rate(per 1,000 live births) in European Union and Mortality rate(per 1,000 live births) in Pakistan?
Offer a terse response. -57.43. In the year 1999, what is the difference between the Mortality rate(per 1,000 live births) of European Union and Mortality rate(per 1,000 live births) of United Arab Emirates?
Provide a succinct answer. -1.43. In the year 1999, what is the difference between the Mortality rate(per 1,000 live births) in Iran and Mortality rate(per 1,000 live births) in Pakistan?
Provide a succinct answer. -41.9. In the year 2000, what is the difference between the Mortality rate(per 1,000 live births) in European Union and Mortality rate(per 1,000 live births) in Iran?
Your answer should be very brief. -14.96. In the year 2000, what is the difference between the Mortality rate(per 1,000 live births) in European Union and Mortality rate(per 1,000 live births) in Pakistan?
Ensure brevity in your answer.  -56.16. In the year 2000, what is the difference between the Mortality rate(per 1,000 live births) in European Union and Mortality rate(per 1,000 live births) in United Arab Emirates?
Keep it short and to the point. -1.36. In the year 2000, what is the difference between the Mortality rate(per 1,000 live births) in Iran and Mortality rate(per 1,000 live births) in Pakistan?
Your response must be concise. -41.2. In the year 2000, what is the difference between the Mortality rate(per 1,000 live births) of Pakistan and Mortality rate(per 1,000 live births) of United Arab Emirates?
Give a very brief answer. 54.8. In the year 2001, what is the difference between the Mortality rate(per 1,000 live births) of European Union and Mortality rate(per 1,000 live births) of Iran?
Offer a very short reply. -14.32. In the year 2001, what is the difference between the Mortality rate(per 1,000 live births) of European Union and Mortality rate(per 1,000 live births) of Pakistan?
Your answer should be very brief. -54.92. In the year 2001, what is the difference between the Mortality rate(per 1,000 live births) in European Union and Mortality rate(per 1,000 live births) in United Arab Emirates?
Offer a terse response. -1.42. In the year 2001, what is the difference between the Mortality rate(per 1,000 live births) of Iran and Mortality rate(per 1,000 live births) of Pakistan?
Provide a succinct answer. -40.6. In the year 2001, what is the difference between the Mortality rate(per 1,000 live births) of Pakistan and Mortality rate(per 1,000 live births) of United Arab Emirates?
Offer a very short reply. 53.5. In the year 2002, what is the difference between the Mortality rate(per 1,000 live births) of European Union and Mortality rate(per 1,000 live births) of Iran?
Make the answer very short. -13.52. In the year 2002, what is the difference between the Mortality rate(per 1,000 live births) of European Union and Mortality rate(per 1,000 live births) of Pakistan?
Give a very brief answer. -53.82. In the year 2002, what is the difference between the Mortality rate(per 1,000 live births) in European Union and Mortality rate(per 1,000 live births) in United Arab Emirates?
Your response must be concise. -1.42. In the year 2002, what is the difference between the Mortality rate(per 1,000 live births) in Iran and Mortality rate(per 1,000 live births) in Pakistan?
Provide a short and direct response. -40.3. In the year 2002, what is the difference between the Mortality rate(per 1,000 live births) of Iran and Mortality rate(per 1,000 live births) of United Arab Emirates?
Provide a succinct answer. 12.1. In the year 2002, what is the difference between the Mortality rate(per 1,000 live births) of Pakistan and Mortality rate(per 1,000 live births) of United Arab Emirates?
Make the answer very short. 52.4. In the year 2003, what is the difference between the Mortality rate(per 1,000 live births) in European Union and Mortality rate(per 1,000 live births) in Iran?
Provide a short and direct response. -12.94. In the year 2003, what is the difference between the Mortality rate(per 1,000 live births) in European Union and Mortality rate(per 1,000 live births) in Pakistan?
Make the answer very short. -52.44. In the year 2003, what is the difference between the Mortality rate(per 1,000 live births) in European Union and Mortality rate(per 1,000 live births) in United Arab Emirates?
Make the answer very short. -1.34. In the year 2003, what is the difference between the Mortality rate(per 1,000 live births) of Iran and Mortality rate(per 1,000 live births) of Pakistan?
Offer a very short reply. -39.5. In the year 2003, what is the difference between the Mortality rate(per 1,000 live births) of Pakistan and Mortality rate(per 1,000 live births) of United Arab Emirates?
Provide a short and direct response. 51.1. In the year 2004, what is the difference between the Mortality rate(per 1,000 live births) of European Union and Mortality rate(per 1,000 live births) of Iran?
Offer a terse response. -12.29. In the year 2004, what is the difference between the Mortality rate(per 1,000 live births) in European Union and Mortality rate(per 1,000 live births) in Pakistan?
Your response must be concise. -51.09. In the year 2004, what is the difference between the Mortality rate(per 1,000 live births) of European Union and Mortality rate(per 1,000 live births) of United Arab Emirates?
Provide a short and direct response. -1.39. In the year 2004, what is the difference between the Mortality rate(per 1,000 live births) of Iran and Mortality rate(per 1,000 live births) of Pakistan?
Make the answer very short. -38.8. In the year 2004, what is the difference between the Mortality rate(per 1,000 live births) in Iran and Mortality rate(per 1,000 live births) in United Arab Emirates?
Offer a terse response. 10.9. In the year 2004, what is the difference between the Mortality rate(per 1,000 live births) in Pakistan and Mortality rate(per 1,000 live births) in United Arab Emirates?
Provide a short and direct response. 49.7. What is the ratio of the Mortality rate(per 1,000 live births) in European Union in 1997 to that in 1998?
Give a very brief answer. 1.05. What is the ratio of the Mortality rate(per 1,000 live births) in Iran in 1997 to that in 1998?
Offer a very short reply. 1.03. What is the ratio of the Mortality rate(per 1,000 live births) in Pakistan in 1997 to that in 1998?
Your answer should be very brief. 1.02. What is the ratio of the Mortality rate(per 1,000 live births) of United Arab Emirates in 1997 to that in 1998?
Give a very brief answer. 1.03. What is the ratio of the Mortality rate(per 1,000 live births) of European Union in 1997 to that in 1999?
Provide a short and direct response. 1.1. What is the ratio of the Mortality rate(per 1,000 live births) of Iran in 1997 to that in 1999?
Provide a succinct answer. 1.07. What is the ratio of the Mortality rate(per 1,000 live births) of Pakistan in 1997 to that in 1999?
Your answer should be very brief. 1.04. What is the ratio of the Mortality rate(per 1,000 live births) of United Arab Emirates in 1997 to that in 1999?
Keep it short and to the point. 1.07. What is the ratio of the Mortality rate(per 1,000 live births) of European Union in 1997 to that in 2000?
Offer a terse response. 1.13. What is the ratio of the Mortality rate(per 1,000 live births) of Iran in 1997 to that in 2000?
Offer a terse response. 1.11. What is the ratio of the Mortality rate(per 1,000 live births) of Pakistan in 1997 to that in 2000?
Keep it short and to the point. 1.07. What is the ratio of the Mortality rate(per 1,000 live births) in United Arab Emirates in 1997 to that in 2000?
Ensure brevity in your answer.  1.11. What is the ratio of the Mortality rate(per 1,000 live births) of European Union in 1997 to that in 2001?
Provide a short and direct response. 1.18. What is the ratio of the Mortality rate(per 1,000 live births) in Iran in 1997 to that in 2001?
Your answer should be compact. 1.16. What is the ratio of the Mortality rate(per 1,000 live births) in Pakistan in 1997 to that in 2001?
Keep it short and to the point. 1.09. What is the ratio of the Mortality rate(per 1,000 live births) of United Arab Emirates in 1997 to that in 2001?
Ensure brevity in your answer.  1.13. What is the ratio of the Mortality rate(per 1,000 live births) of European Union in 1997 to that in 2002?
Provide a short and direct response. 1.21. What is the ratio of the Mortality rate(per 1,000 live births) in Iran in 1997 to that in 2002?
Your answer should be very brief. 1.22. What is the ratio of the Mortality rate(per 1,000 live births) of Pakistan in 1997 to that in 2002?
Offer a terse response. 1.12. What is the ratio of the Mortality rate(per 1,000 live births) of United Arab Emirates in 1997 to that in 2002?
Ensure brevity in your answer.  1.15. What is the ratio of the Mortality rate(per 1,000 live births) in European Union in 1997 to that in 2003?
Offer a terse response. 1.24. What is the ratio of the Mortality rate(per 1,000 live births) of Iran in 1997 to that in 2003?
Offer a very short reply. 1.27. What is the ratio of the Mortality rate(per 1,000 live births) of Pakistan in 1997 to that in 2003?
Ensure brevity in your answer.  1.15. What is the ratio of the Mortality rate(per 1,000 live births) in United Arab Emirates in 1997 to that in 2003?
Your answer should be compact. 1.19. What is the ratio of the Mortality rate(per 1,000 live births) in European Union in 1997 to that in 2004?
Make the answer very short. 1.29. What is the ratio of the Mortality rate(per 1,000 live births) of Iran in 1997 to that in 2004?
Keep it short and to the point. 1.33. What is the ratio of the Mortality rate(per 1,000 live births) in Pakistan in 1997 to that in 2004?
Ensure brevity in your answer.  1.18. What is the ratio of the Mortality rate(per 1,000 live births) of United Arab Emirates in 1997 to that in 2004?
Ensure brevity in your answer.  1.22. What is the ratio of the Mortality rate(per 1,000 live births) of European Union in 1998 to that in 1999?
Offer a very short reply. 1.05. What is the ratio of the Mortality rate(per 1,000 live births) of Iran in 1998 to that in 1999?
Make the answer very short. 1.04. What is the ratio of the Mortality rate(per 1,000 live births) of Pakistan in 1998 to that in 1999?
Ensure brevity in your answer.  1.02. What is the ratio of the Mortality rate(per 1,000 live births) in United Arab Emirates in 1998 to that in 1999?
Provide a short and direct response. 1.03. What is the ratio of the Mortality rate(per 1,000 live births) in European Union in 1998 to that in 2000?
Ensure brevity in your answer.  1.08. What is the ratio of the Mortality rate(per 1,000 live births) of Iran in 1998 to that in 2000?
Provide a succinct answer. 1.07. What is the ratio of the Mortality rate(per 1,000 live births) in Pakistan in 1998 to that in 2000?
Provide a succinct answer. 1.05. What is the ratio of the Mortality rate(per 1,000 live births) in United Arab Emirates in 1998 to that in 2000?
Offer a very short reply. 1.07. What is the ratio of the Mortality rate(per 1,000 live births) of European Union in 1998 to that in 2001?
Give a very brief answer. 1.12. What is the ratio of the Mortality rate(per 1,000 live births) in Iran in 1998 to that in 2001?
Your response must be concise. 1.12. What is the ratio of the Mortality rate(per 1,000 live births) in Pakistan in 1998 to that in 2001?
Keep it short and to the point. 1.07. What is the ratio of the Mortality rate(per 1,000 live births) of United Arab Emirates in 1998 to that in 2001?
Offer a very short reply. 1.09. What is the ratio of the Mortality rate(per 1,000 live births) of European Union in 1998 to that in 2002?
Your answer should be compact. 1.15. What is the ratio of the Mortality rate(per 1,000 live births) of Iran in 1998 to that in 2002?
Ensure brevity in your answer.  1.18. What is the ratio of the Mortality rate(per 1,000 live births) in Pakistan in 1998 to that in 2002?
Ensure brevity in your answer.  1.09. What is the ratio of the Mortality rate(per 1,000 live births) in United Arab Emirates in 1998 to that in 2002?
Give a very brief answer. 1.11. What is the ratio of the Mortality rate(per 1,000 live births) of European Union in 1998 to that in 2003?
Offer a terse response. 1.19. What is the ratio of the Mortality rate(per 1,000 live births) in Iran in 1998 to that in 2003?
Your response must be concise. 1.23. What is the ratio of the Mortality rate(per 1,000 live births) of Pakistan in 1998 to that in 2003?
Ensure brevity in your answer.  1.12. What is the ratio of the Mortality rate(per 1,000 live births) in United Arab Emirates in 1998 to that in 2003?
Offer a very short reply. 1.15. What is the ratio of the Mortality rate(per 1,000 live births) of European Union in 1998 to that in 2004?
Your response must be concise. 1.23. What is the ratio of the Mortality rate(per 1,000 live births) in Iran in 1998 to that in 2004?
Give a very brief answer. 1.29. What is the ratio of the Mortality rate(per 1,000 live births) in Pakistan in 1998 to that in 2004?
Your answer should be compact. 1.15. What is the ratio of the Mortality rate(per 1,000 live births) in United Arab Emirates in 1998 to that in 2004?
Your answer should be very brief. 1.18. What is the ratio of the Mortality rate(per 1,000 live births) in European Union in 1999 to that in 2000?
Offer a very short reply. 1.03. What is the ratio of the Mortality rate(per 1,000 live births) of Iran in 1999 to that in 2000?
Your response must be concise. 1.04. What is the ratio of the Mortality rate(per 1,000 live births) of Pakistan in 1999 to that in 2000?
Make the answer very short. 1.02. What is the ratio of the Mortality rate(per 1,000 live births) of United Arab Emirates in 1999 to that in 2000?
Offer a terse response. 1.04. What is the ratio of the Mortality rate(per 1,000 live births) in European Union in 1999 to that in 2001?
Ensure brevity in your answer.  1.07. What is the ratio of the Mortality rate(per 1,000 live births) of Iran in 1999 to that in 2001?
Ensure brevity in your answer.  1.08. What is the ratio of the Mortality rate(per 1,000 live births) of Pakistan in 1999 to that in 2001?
Provide a succinct answer. 1.05. What is the ratio of the Mortality rate(per 1,000 live births) in United Arab Emirates in 1999 to that in 2001?
Your response must be concise. 1.05. What is the ratio of the Mortality rate(per 1,000 live births) of European Union in 1999 to that in 2002?
Provide a succinct answer. 1.1. What is the ratio of the Mortality rate(per 1,000 live births) of Iran in 1999 to that in 2002?
Ensure brevity in your answer.  1.14. What is the ratio of the Mortality rate(per 1,000 live births) of Pakistan in 1999 to that in 2002?
Keep it short and to the point. 1.07. What is the ratio of the Mortality rate(per 1,000 live births) in United Arab Emirates in 1999 to that in 2002?
Keep it short and to the point. 1.07. What is the ratio of the Mortality rate(per 1,000 live births) in European Union in 1999 to that in 2003?
Give a very brief answer. 1.13. What is the ratio of the Mortality rate(per 1,000 live births) in Iran in 1999 to that in 2003?
Your answer should be compact. 1.18. What is the ratio of the Mortality rate(per 1,000 live births) in Pakistan in 1999 to that in 2003?
Provide a succinct answer. 1.1. What is the ratio of the Mortality rate(per 1,000 live births) in United Arab Emirates in 1999 to that in 2003?
Keep it short and to the point. 1.12. What is the ratio of the Mortality rate(per 1,000 live births) of European Union in 1999 to that in 2004?
Your answer should be very brief. 1.18. What is the ratio of the Mortality rate(per 1,000 live births) in Iran in 1999 to that in 2004?
Offer a terse response. 1.24. What is the ratio of the Mortality rate(per 1,000 live births) in Pakistan in 1999 to that in 2004?
Provide a succinct answer. 1.13. What is the ratio of the Mortality rate(per 1,000 live births) in United Arab Emirates in 1999 to that in 2004?
Provide a short and direct response. 1.14. What is the ratio of the Mortality rate(per 1,000 live births) in European Union in 2000 to that in 2001?
Provide a succinct answer. 1.04. What is the ratio of the Mortality rate(per 1,000 live births) of Iran in 2000 to that in 2001?
Provide a succinct answer. 1.04. What is the ratio of the Mortality rate(per 1,000 live births) of Pakistan in 2000 to that in 2001?
Provide a succinct answer. 1.02. What is the ratio of the Mortality rate(per 1,000 live births) in United Arab Emirates in 2000 to that in 2001?
Offer a very short reply. 1.02. What is the ratio of the Mortality rate(per 1,000 live births) of European Union in 2000 to that in 2002?
Make the answer very short. 1.07. What is the ratio of the Mortality rate(per 1,000 live births) of Iran in 2000 to that in 2002?
Ensure brevity in your answer.  1.1. What is the ratio of the Mortality rate(per 1,000 live births) of Pakistan in 2000 to that in 2002?
Make the answer very short. 1.04. What is the ratio of the Mortality rate(per 1,000 live births) of European Union in 2000 to that in 2003?
Your answer should be compact. 1.1. What is the ratio of the Mortality rate(per 1,000 live births) in Pakistan in 2000 to that in 2003?
Your answer should be compact. 1.07. What is the ratio of the Mortality rate(per 1,000 live births) in United Arab Emirates in 2000 to that in 2003?
Your answer should be very brief. 1.08. What is the ratio of the Mortality rate(per 1,000 live births) of European Union in 2000 to that in 2004?
Offer a terse response. 1.14. What is the ratio of the Mortality rate(per 1,000 live births) of Iran in 2000 to that in 2004?
Offer a very short reply. 1.2. What is the ratio of the Mortality rate(per 1,000 live births) of Pakistan in 2000 to that in 2004?
Offer a very short reply. 1.1. What is the ratio of the Mortality rate(per 1,000 live births) in United Arab Emirates in 2000 to that in 2004?
Make the answer very short. 1.1. What is the ratio of the Mortality rate(per 1,000 live births) of European Union in 2001 to that in 2002?
Offer a very short reply. 1.03. What is the ratio of the Mortality rate(per 1,000 live births) in Iran in 2001 to that in 2002?
Keep it short and to the point. 1.05. What is the ratio of the Mortality rate(per 1,000 live births) of Pakistan in 2001 to that in 2002?
Offer a terse response. 1.02. What is the ratio of the Mortality rate(per 1,000 live births) of United Arab Emirates in 2001 to that in 2002?
Offer a very short reply. 1.02. What is the ratio of the Mortality rate(per 1,000 live births) of European Union in 2001 to that in 2003?
Provide a short and direct response. 1.06. What is the ratio of the Mortality rate(per 1,000 live births) of Iran in 2001 to that in 2003?
Provide a short and direct response. 1.1. What is the ratio of the Mortality rate(per 1,000 live births) of Pakistan in 2001 to that in 2003?
Your response must be concise. 1.05. What is the ratio of the Mortality rate(per 1,000 live births) in United Arab Emirates in 2001 to that in 2003?
Make the answer very short. 1.06. What is the ratio of the Mortality rate(per 1,000 live births) in European Union in 2001 to that in 2004?
Offer a very short reply. 1.1. What is the ratio of the Mortality rate(per 1,000 live births) of Iran in 2001 to that in 2004?
Offer a very short reply. 1.15. What is the ratio of the Mortality rate(per 1,000 live births) in Pakistan in 2001 to that in 2004?
Make the answer very short. 1.08. What is the ratio of the Mortality rate(per 1,000 live births) in United Arab Emirates in 2001 to that in 2004?
Offer a terse response. 1.08. What is the ratio of the Mortality rate(per 1,000 live births) in European Union in 2002 to that in 2003?
Your response must be concise. 1.03. What is the ratio of the Mortality rate(per 1,000 live births) in Iran in 2002 to that in 2003?
Your response must be concise. 1.04. What is the ratio of the Mortality rate(per 1,000 live births) of Pakistan in 2002 to that in 2003?
Your response must be concise. 1.03. What is the ratio of the Mortality rate(per 1,000 live births) in United Arab Emirates in 2002 to that in 2003?
Offer a terse response. 1.04. What is the ratio of the Mortality rate(per 1,000 live births) in European Union in 2002 to that in 2004?
Provide a short and direct response. 1.07. What is the ratio of the Mortality rate(per 1,000 live births) in Iran in 2002 to that in 2004?
Your response must be concise. 1.09. What is the ratio of the Mortality rate(per 1,000 live births) in Pakistan in 2002 to that in 2004?
Give a very brief answer. 1.05. What is the ratio of the Mortality rate(per 1,000 live births) in United Arab Emirates in 2002 to that in 2004?
Your answer should be very brief. 1.06. What is the ratio of the Mortality rate(per 1,000 live births) in European Union in 2003 to that in 2004?
Your answer should be compact. 1.04. What is the ratio of the Mortality rate(per 1,000 live births) of Iran in 2003 to that in 2004?
Make the answer very short. 1.05. What is the ratio of the Mortality rate(per 1,000 live births) in Pakistan in 2003 to that in 2004?
Your response must be concise. 1.03. What is the ratio of the Mortality rate(per 1,000 live births) in United Arab Emirates in 2003 to that in 2004?
Offer a terse response. 1.02. What is the difference between the highest and the second highest Mortality rate(per 1,000 live births) of European Union?
Ensure brevity in your answer.  0.22. What is the difference between the highest and the second highest Mortality rate(per 1,000 live births) in Iran?
Your response must be concise. 0.7. What is the difference between the highest and the second highest Mortality rate(per 1,000 live births) of United Arab Emirates?
Give a very brief answer. 0.2. What is the difference between the highest and the lowest Mortality rate(per 1,000 live births) of European Union?
Give a very brief answer. 1.09. What is the difference between the highest and the lowest Mortality rate(per 1,000 live births) of Pakistan?
Provide a short and direct response. 9.7. What is the difference between the highest and the lowest Mortality rate(per 1,000 live births) in United Arab Emirates?
Offer a very short reply. 1.1. 